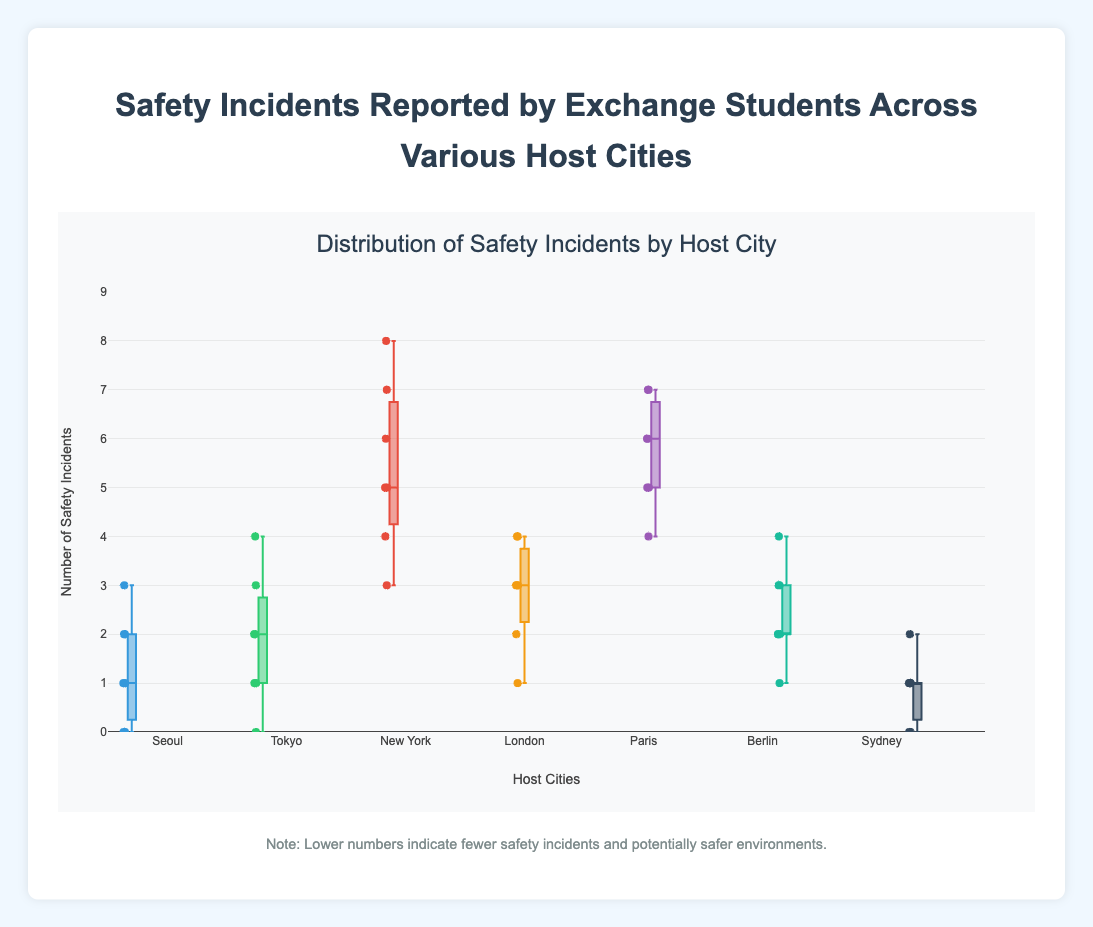What is the title of the figure? The title of the figure is located at the top and it describes the content of the plot. By looking at the figure, we see that the title is "Distribution of Safety Incidents by Host City."
Answer: Distribution of Safety Incidents by Host City Which city shows the highest range of safety incidents? Range in a box plot refers to the distance between the minimum and maximum values. By comparing the vertical spread of the boxes, we see that New York has the highest range, stretching from 3 to 8.
Answer: New York What is the median number of safety incidents in Seoul? The median is the line inside each box. The line inside the box for Seoul corresponds to the median, which is 2.
Answer: 2 Which city has the lowest number of data points indicating safety incidents? Each city has a specific number of individual points within the box plot. By counting these points, we notice that Seoul has the fewest data points with only seven entries.
Answer: Seoul Compare the median values of Paris and London. Which has a higher median? The median is indicated by a line within each box. Paris has a median line at 6, while London has a median line at 3. Therefore, Paris has a higher median.
Answer: Paris How many outliers are reported in Tokyo? Outliers are typically shown as points outside the whiskers of the box plot. In the Tokyo plot, we observe one outlier positioned at a distance from the box, specifically at 4.
Answer: 1 What is the interquartile range (IQR) of safety incidents in Berlin? The IQR is the distance between the first quartile (Q1) and the third quartile (Q3). For Berlin, Q1 is 2 and Q3 is 3. Therefore, the IQR is 3 - 2 = 1.
Answer: 1 Which city has the most consistent (least variable) safety incident reports? Consistency and low variability are indicated by a smaller box. Sydney has the smallest box ranging from 0 to 2, indicating the least variability in safety incidents.
Answer: Sydney What is the maximum number of safety incidents reported in Paris? The top whisker and any points above it indicate the maximum value. In the case of Paris, the highest point, or the top whisker, is at 7.
Answer: 7 Between Tokyo and Seoul, which city has a higher upper quartile (Q3)? The upper quartile (Q3) is the top edge of the box. For Seoul, Q3 is at 2, while for Tokyo, Q3 is at 3. Thus, Tokyo has a higher upper quartile.
Answer: Tokyo 